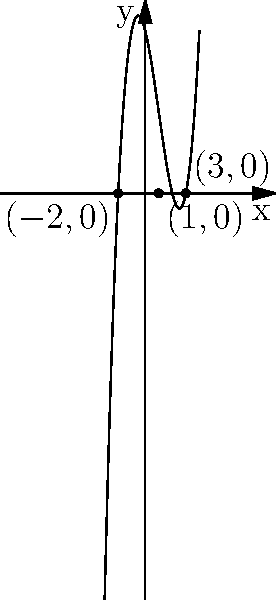Consider the polynomial function $f(x) = x^3 - 3x^2 - 4x + 12$ graphed above. How does the number of real roots of this function relate to the number of x-intercepts on its graph? Provide a cognitive explanation for this relationship. To answer this question, let's break it down step-by-step:

1. Definition of roots: The roots of a polynomial function are the values of x that make the function equal to zero, i.e., $f(x) = 0$.

2. Definition of x-intercepts: X-intercepts are the points where a graph crosses the x-axis, i.e., where y = 0.

3. Observation of the graph: We can see that the graph crosses the x-axis at three points: $(-2,0)$, $(1,0)$, and $(3,0)$.

4. Connection between roots and x-intercepts: When $y = 0$, $f(x) = 0$. This means that the x-coordinates of the x-intercepts are the roots of the function.

5. Counting: There are 3 x-intercepts visible on the graph, which correspond to 3 real roots of the polynomial function.

6. Cognitive explanation: Our visual system can quickly identify the points where the curve intersects the x-axis. This perceptual process aligns with the abstract concept of finding roots algebraically. The brain efficiently translates the visual information (x-intercepts) into mathematical understanding (roots).

7. Generalization: For any polynomial function, the number of real roots will always equal the number of x-intercepts on its graph. This is because both concepts represent the same mathematical idea: where the function equals zero.

8. Cognitive benefit: This graphical representation allows for rapid estimation of the number and approximate location of roots, which can be particularly useful in problem-solving and hypothesis generation in various fields of psychology and cognitive science.
Answer: The number of real roots (3) equals the number of x-intercepts (3), providing a visual representation of the algebraic concept of roots. 